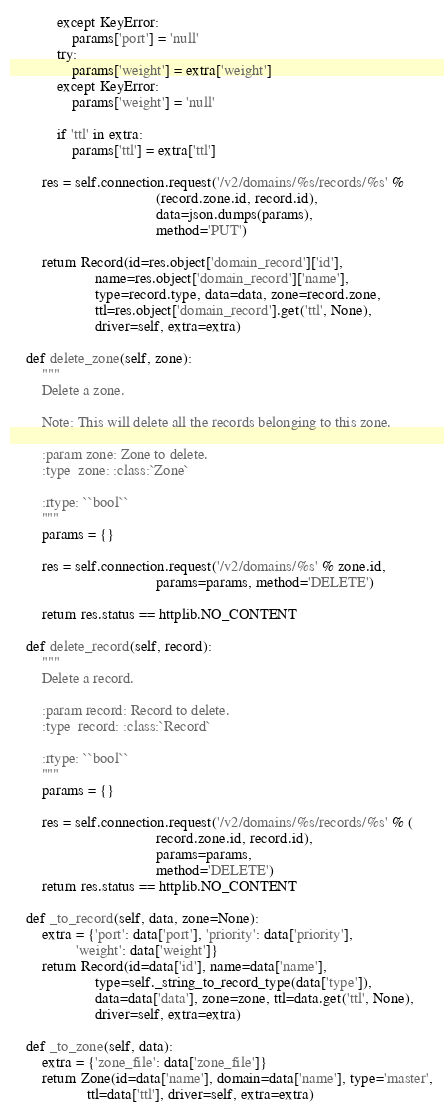<code> <loc_0><loc_0><loc_500><loc_500><_Python_>            except KeyError:
                params['port'] = 'null'
            try:
                params['weight'] = extra['weight']
            except KeyError:
                params['weight'] = 'null'

            if 'ttl' in extra:
                params['ttl'] = extra['ttl']

        res = self.connection.request('/v2/domains/%s/records/%s' %
                                      (record.zone.id, record.id),
                                      data=json.dumps(params),
                                      method='PUT')

        return Record(id=res.object['domain_record']['id'],
                      name=res.object['domain_record']['name'],
                      type=record.type, data=data, zone=record.zone,
                      ttl=res.object['domain_record'].get('ttl', None),
                      driver=self, extra=extra)

    def delete_zone(self, zone):
        """
        Delete a zone.

        Note: This will delete all the records belonging to this zone.

        :param zone: Zone to delete.
        :type  zone: :class:`Zone`

        :rtype: ``bool``
        """
        params = {}

        res = self.connection.request('/v2/domains/%s' % zone.id,
                                      params=params, method='DELETE')

        return res.status == httplib.NO_CONTENT

    def delete_record(self, record):
        """
        Delete a record.

        :param record: Record to delete.
        :type  record: :class:`Record`

        :rtype: ``bool``
        """
        params = {}

        res = self.connection.request('/v2/domains/%s/records/%s' % (
                                      record.zone.id, record.id),
                                      params=params,
                                      method='DELETE')
        return res.status == httplib.NO_CONTENT

    def _to_record(self, data, zone=None):
        extra = {'port': data['port'], 'priority': data['priority'],
                 'weight': data['weight']}
        return Record(id=data['id'], name=data['name'],
                      type=self._string_to_record_type(data['type']),
                      data=data['data'], zone=zone, ttl=data.get('ttl', None),
                      driver=self, extra=extra)

    def _to_zone(self, data):
        extra = {'zone_file': data['zone_file']}
        return Zone(id=data['name'], domain=data['name'], type='master',
                    ttl=data['ttl'], driver=self, extra=extra)
</code> 